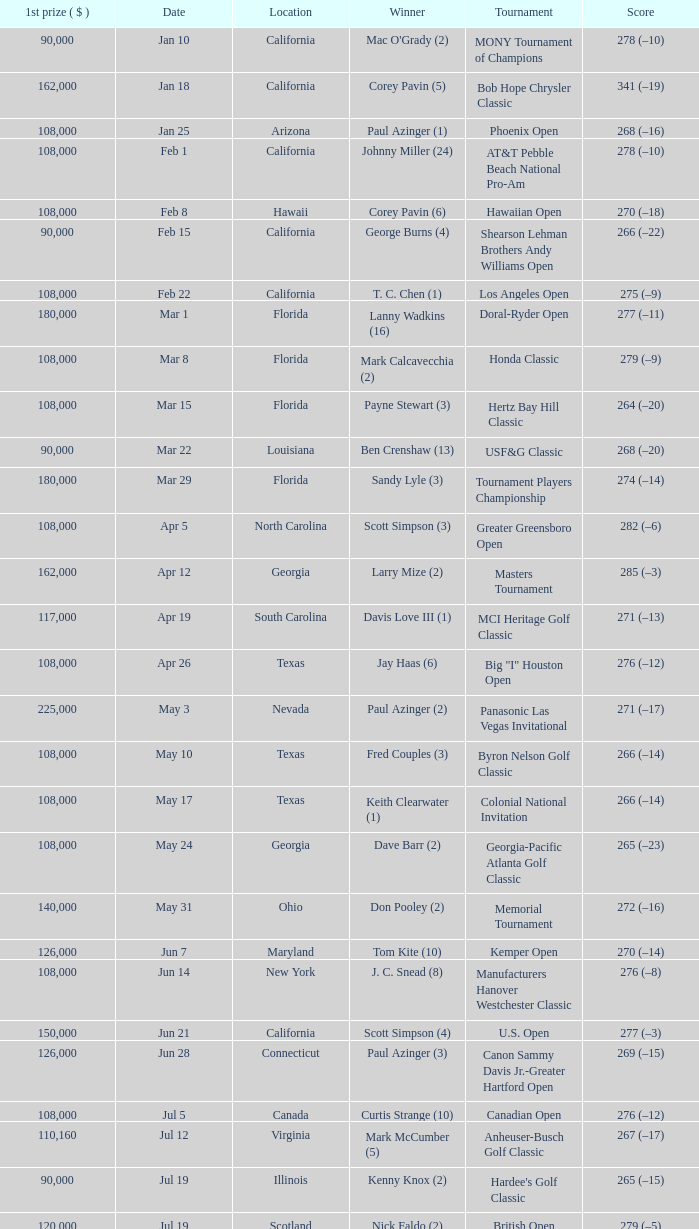What is the date where the winner was Tom Kite (10)? Jun 7. 